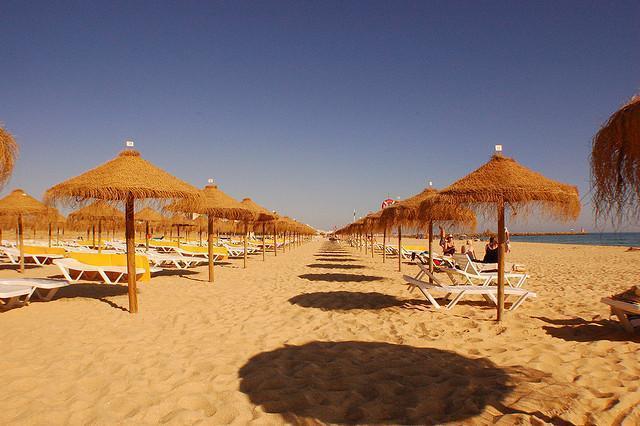How many umbrellas are in the picture?
Give a very brief answer. 3. 